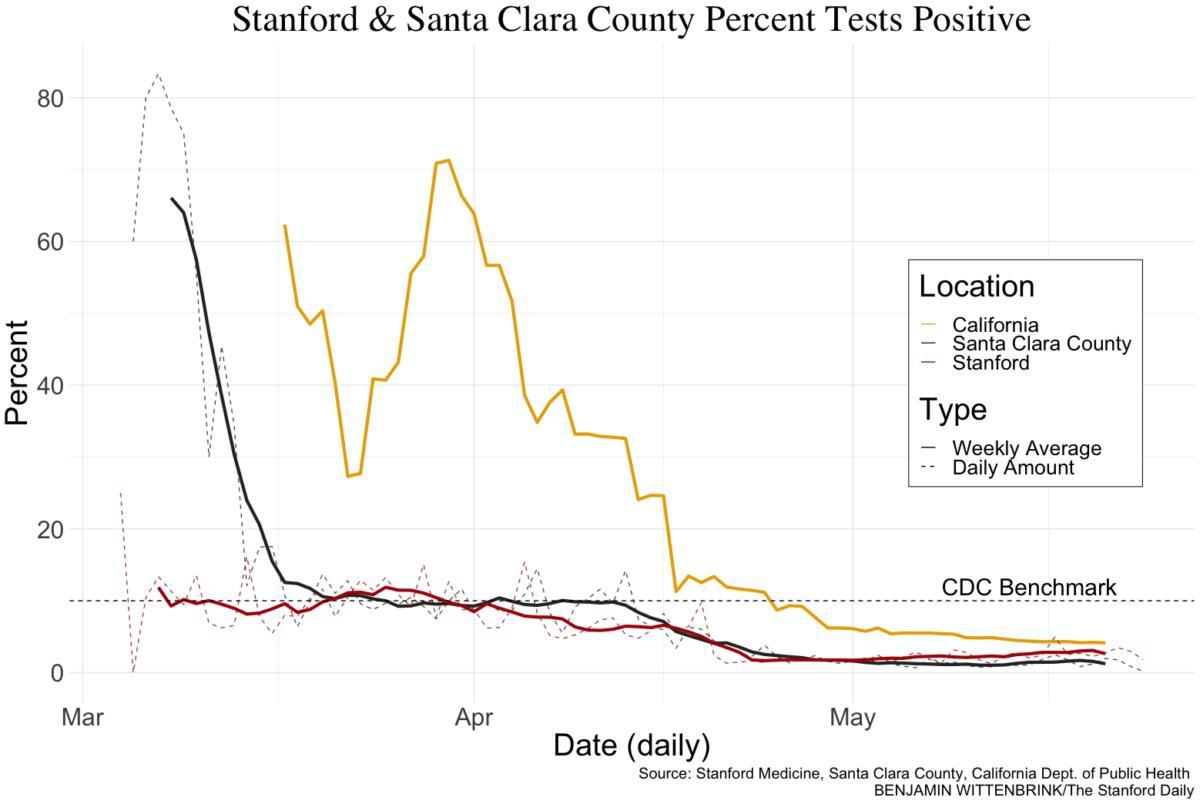Which line is used to represent Daily Amount-bold or dotted?
Answer the question with a short phrase. dotted Which color is used to represent Stanford-yellow, red, or blue? red 